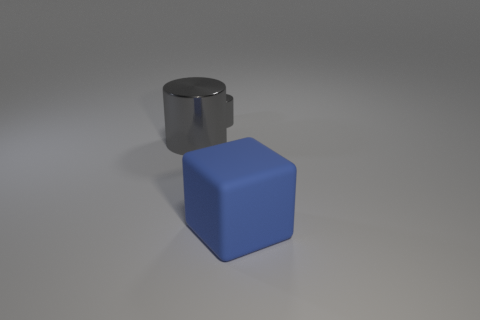Subtract all cylinders. How many objects are left? 1 Add 3 big things. How many big things are left? 5 Add 2 gray metal cylinders. How many gray metal cylinders exist? 4 Add 2 large green metallic blocks. How many objects exist? 5 Subtract 0 cyan balls. How many objects are left? 3 Subtract all gray cubes. Subtract all yellow cylinders. How many cubes are left? 1 Subtract all large blue blocks. Subtract all large metallic cylinders. How many objects are left? 1 